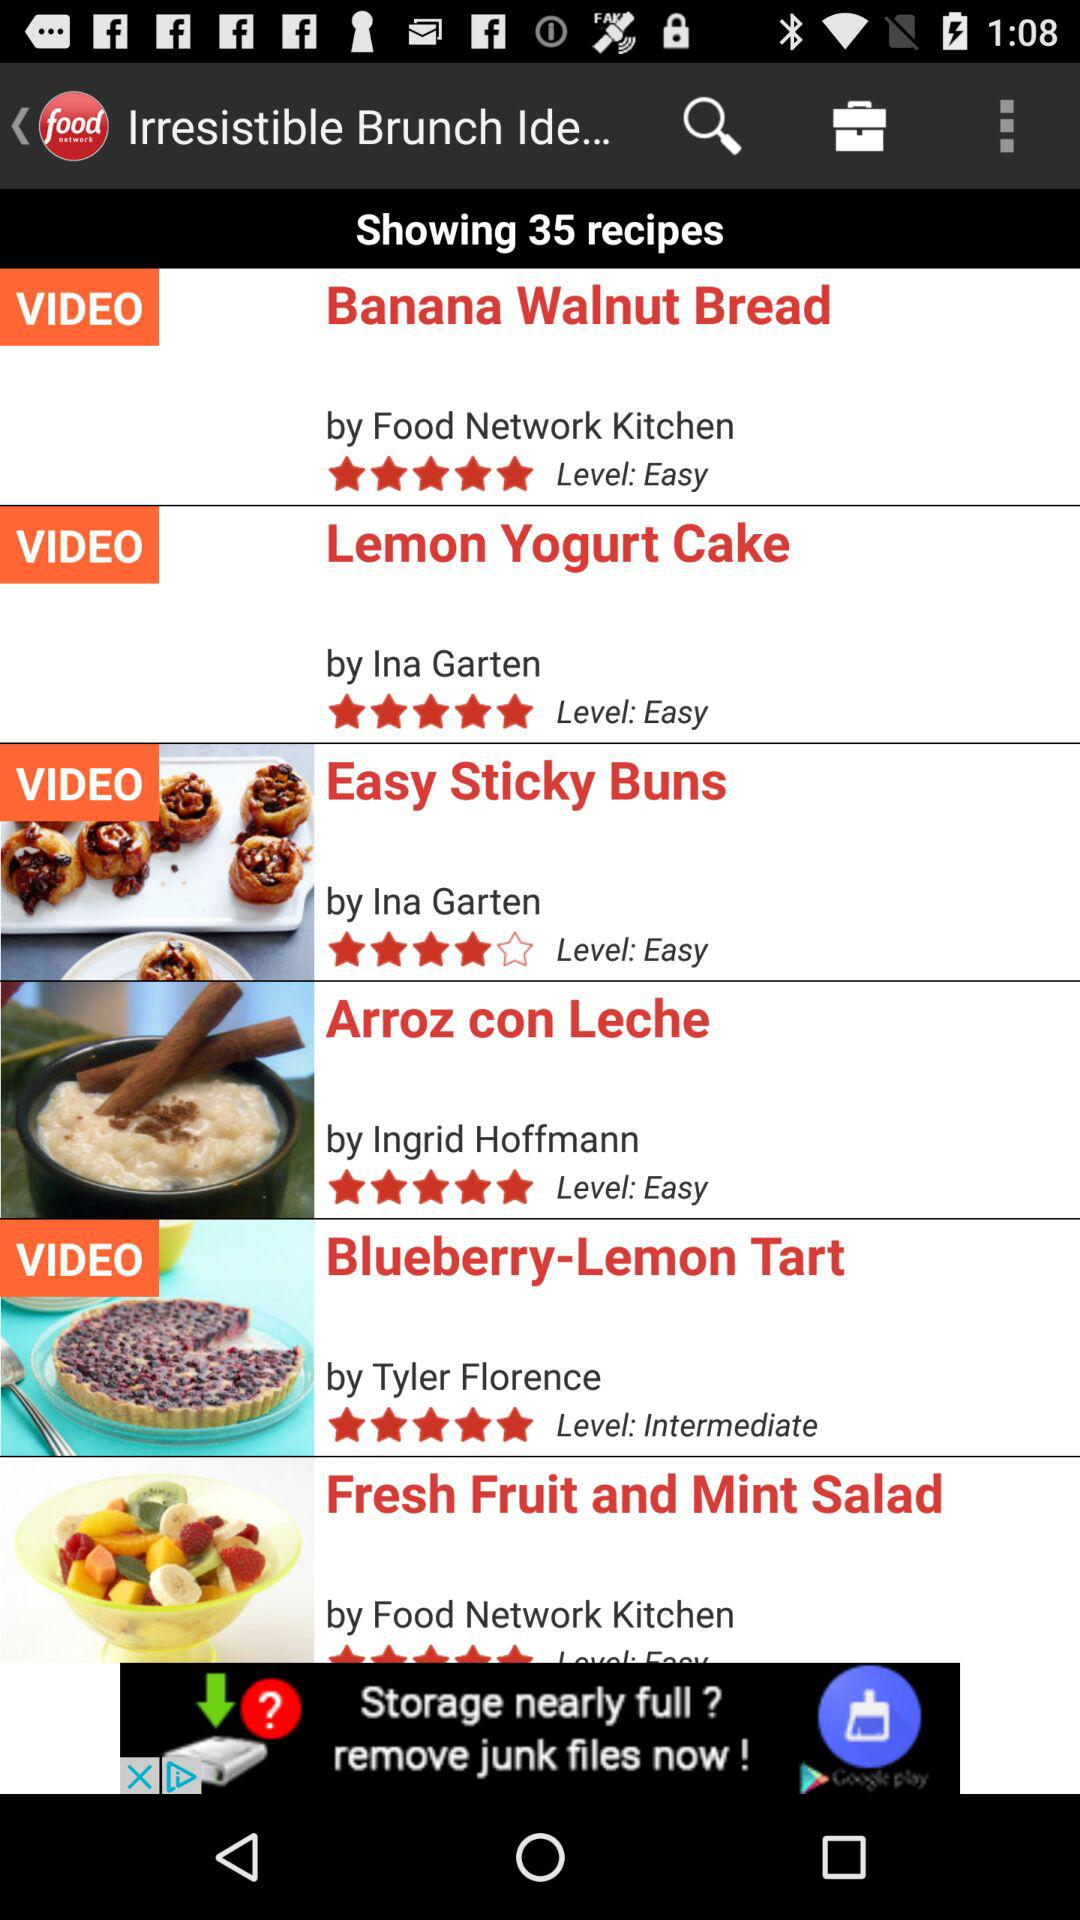Who made the "Blueberry-Lemon Tart" video? The "Blueberry-Lemon Tart" video was made by Tyler Florence. 